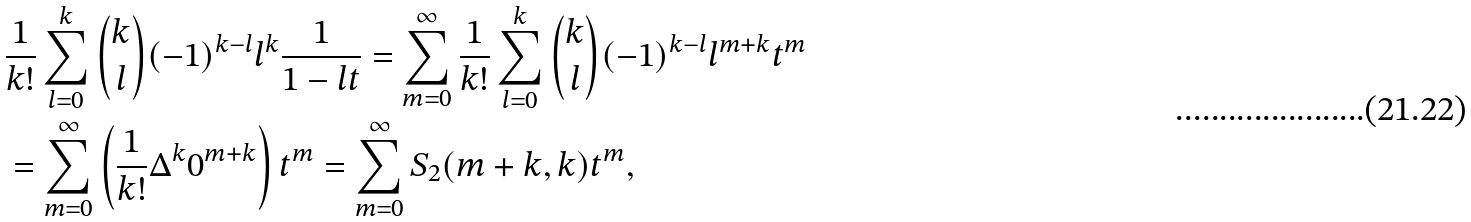Convert formula to latex. <formula><loc_0><loc_0><loc_500><loc_500>& \frac { 1 } { k ! } \sum _ { l = 0 } ^ { k } { k \choose l } ( - 1 ) ^ { k - l } l ^ { k } \frac { 1 } { 1 - l t } = \sum _ { m = 0 } ^ { \infty } \frac { 1 } { k ! } \sum _ { l = 0 } ^ { k } { k \choose l } ( - 1 ) ^ { k - l } l ^ { m + k } t ^ { m } \\ & = \sum _ { m = 0 } ^ { \infty } \left ( \frac { 1 } { k ! } \Delta ^ { k } 0 ^ { m + k } \right ) t ^ { m } = \sum _ { m = 0 } ^ { \infty } S _ { 2 } ( m + k , k ) t ^ { m } ,</formula> 